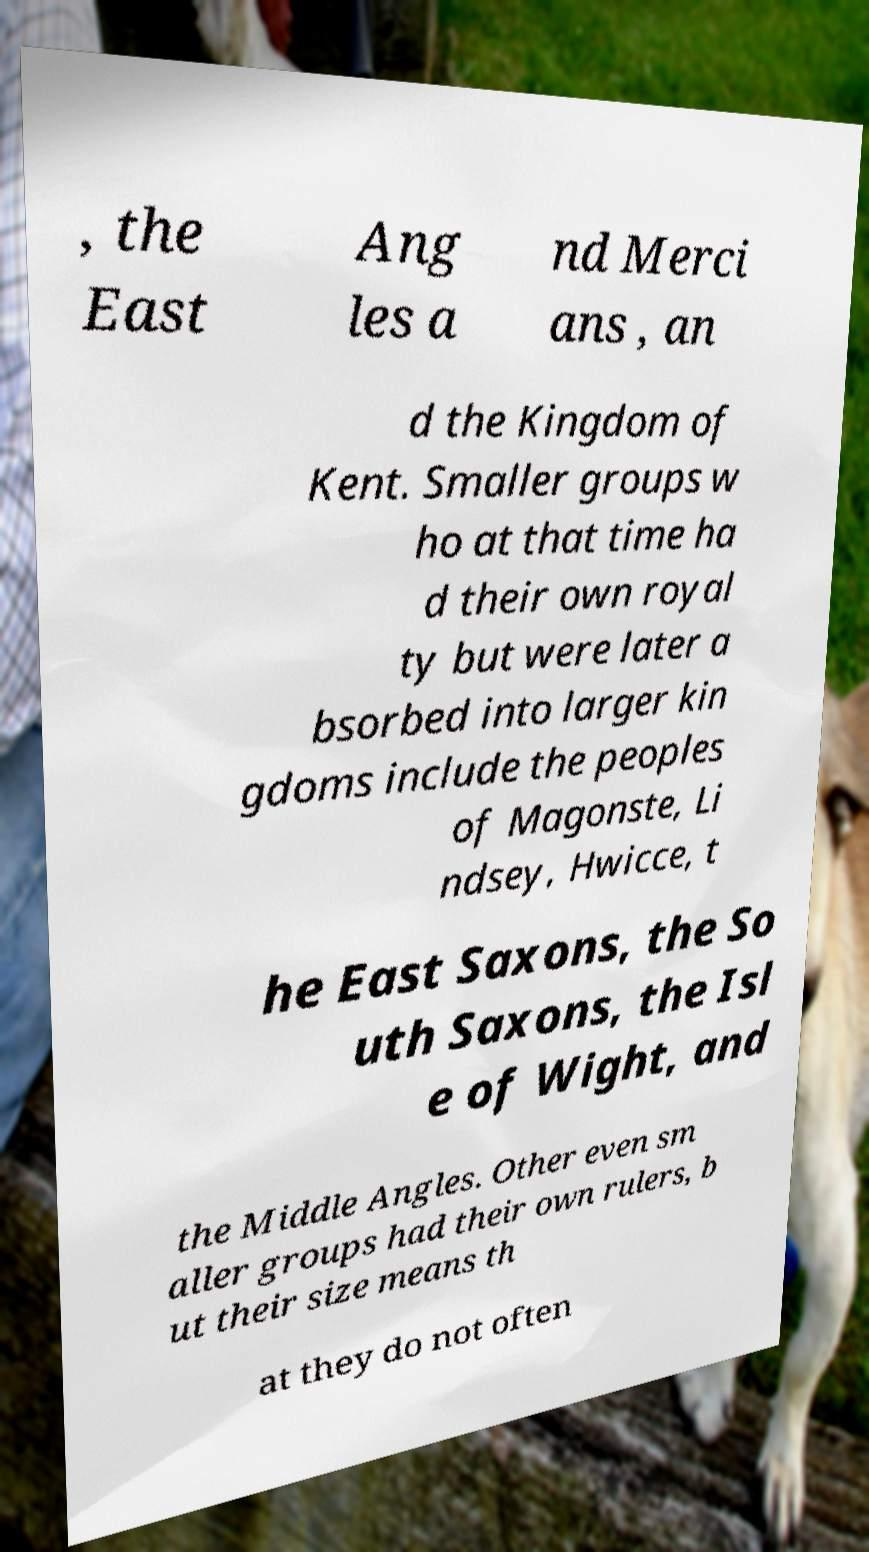I need the written content from this picture converted into text. Can you do that? , the East Ang les a nd Merci ans , an d the Kingdom of Kent. Smaller groups w ho at that time ha d their own royal ty but were later a bsorbed into larger kin gdoms include the peoples of Magonste, Li ndsey, Hwicce, t he East Saxons, the So uth Saxons, the Isl e of Wight, and the Middle Angles. Other even sm aller groups had their own rulers, b ut their size means th at they do not often 